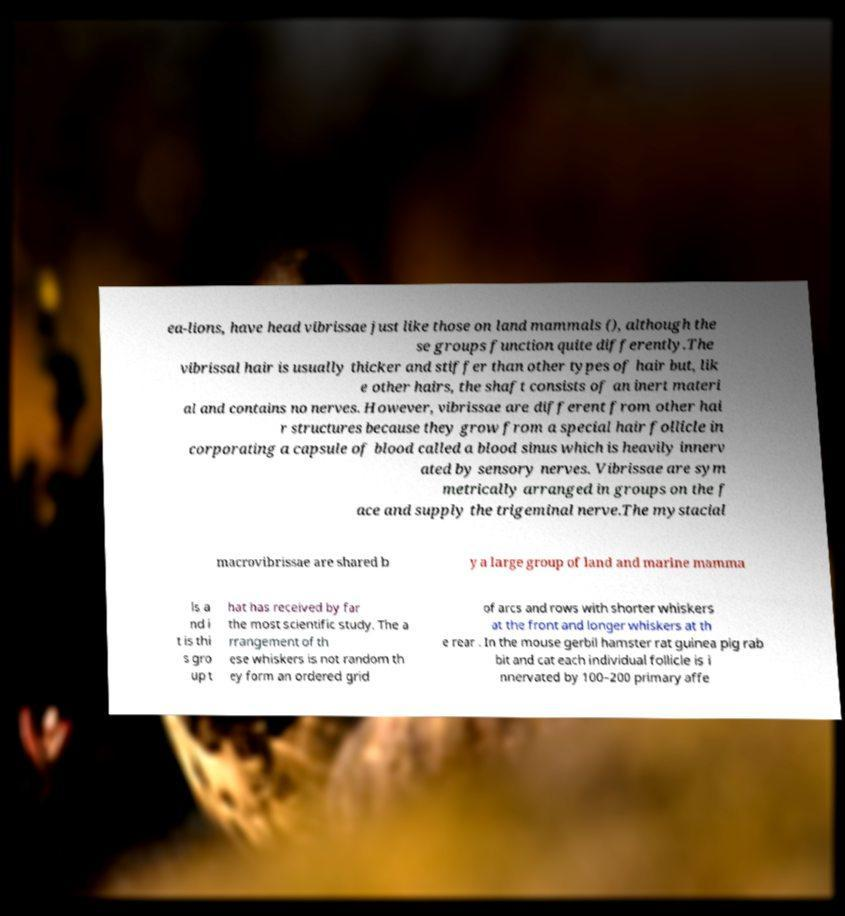For documentation purposes, I need the text within this image transcribed. Could you provide that? ea-lions, have head vibrissae just like those on land mammals (), although the se groups function quite differently.The vibrissal hair is usually thicker and stiffer than other types of hair but, lik e other hairs, the shaft consists of an inert materi al and contains no nerves. However, vibrissae are different from other hai r structures because they grow from a special hair follicle in corporating a capsule of blood called a blood sinus which is heavily innerv ated by sensory nerves. Vibrissae are sym metrically arranged in groups on the f ace and supply the trigeminal nerve.The mystacial macrovibrissae are shared b y a large group of land and marine mamma ls a nd i t is thi s gro up t hat has received by far the most scientific study. The a rrangement of th ese whiskers is not random th ey form an ordered grid of arcs and rows with shorter whiskers at the front and longer whiskers at th e rear . In the mouse gerbil hamster rat guinea pig rab bit and cat each individual follicle is i nnervated by 100–200 primary affe 